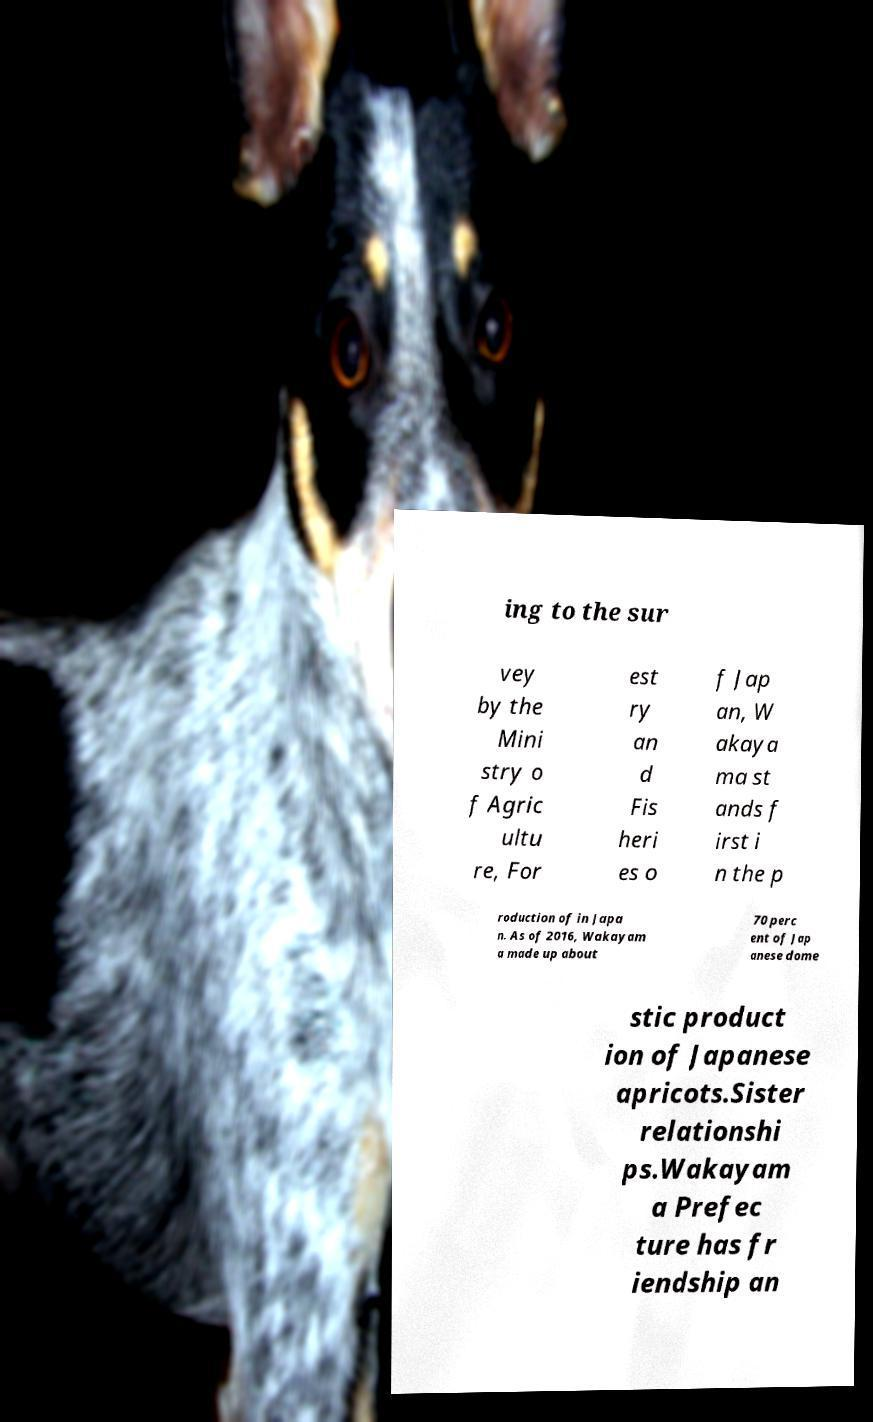Could you assist in decoding the text presented in this image and type it out clearly? ing to the sur vey by the Mini stry o f Agric ultu re, For est ry an d Fis heri es o f Jap an, W akaya ma st ands f irst i n the p roduction of in Japa n. As of 2016, Wakayam a made up about 70 perc ent of Jap anese dome stic product ion of Japanese apricots.Sister relationshi ps.Wakayam a Prefec ture has fr iendship an 